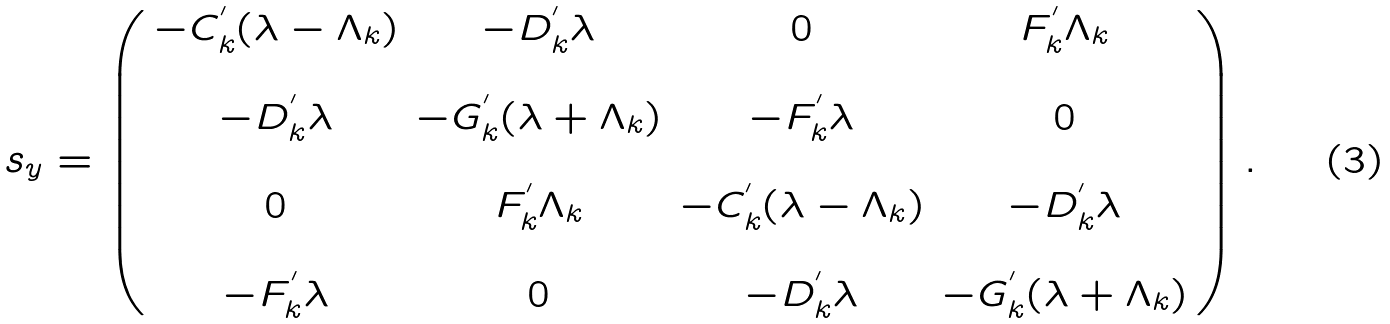Convert formula to latex. <formula><loc_0><loc_0><loc_500><loc_500>s _ { y } = \left ( \begin{array} { c c c c } - C _ { k } ^ { ^ { \prime } } ( \lambda - \Lambda _ { k } ) & - D _ { k } ^ { ^ { \prime } } \lambda & 0 & F _ { k } ^ { ^ { \prime } } \Lambda _ { k } \\ \\ - D _ { k } ^ { ^ { \prime } } \lambda & - G _ { k } ^ { ^ { \prime } } ( \lambda + \Lambda _ { k } ) & - F _ { k } ^ { ^ { \prime } } \lambda & 0 \\ \\ 0 & F _ { k } ^ { ^ { \prime } } \Lambda _ { k } & - C _ { k } ^ { ^ { \prime } } ( \lambda - \Lambda _ { k } ) & - D _ { k } ^ { ^ { \prime } } \lambda \\ \\ - F _ { k } ^ { ^ { \prime } } \lambda & 0 & - D _ { k } ^ { ^ { \prime } } \lambda & - G _ { k } ^ { ^ { \prime } } ( \lambda + \Lambda _ { k } ) \end{array} \right ) .</formula> 